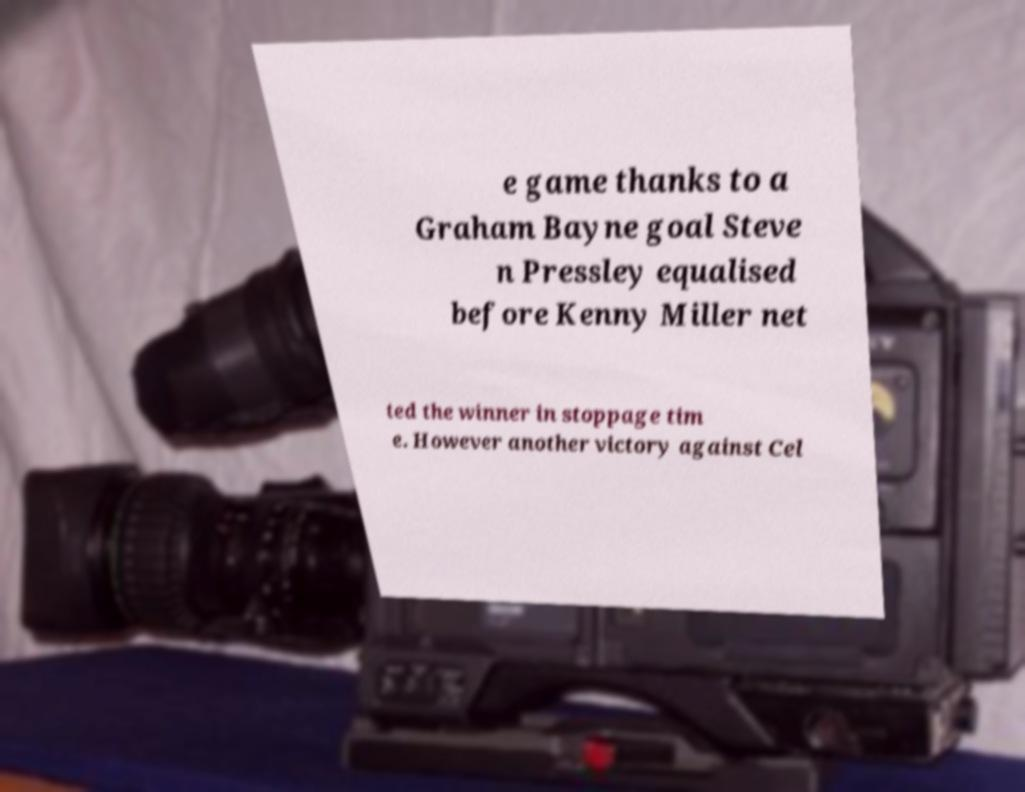What messages or text are displayed in this image? I need them in a readable, typed format. e game thanks to a Graham Bayne goal Steve n Pressley equalised before Kenny Miller net ted the winner in stoppage tim e. However another victory against Cel 